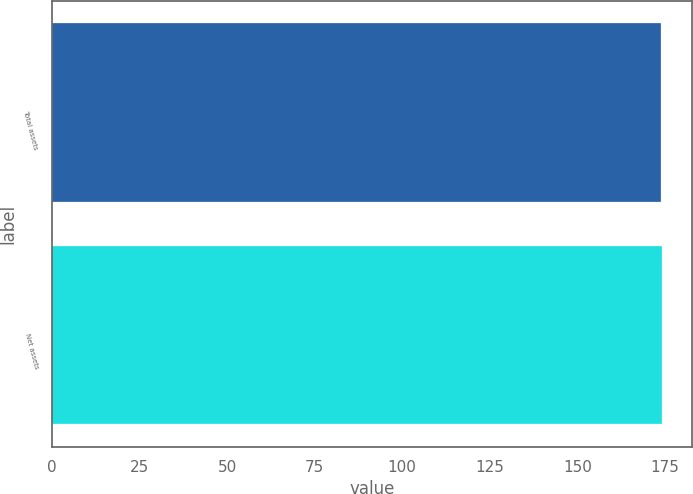<chart> <loc_0><loc_0><loc_500><loc_500><bar_chart><fcel>Total assets<fcel>Net assets<nl><fcel>174<fcel>174.1<nl></chart> 